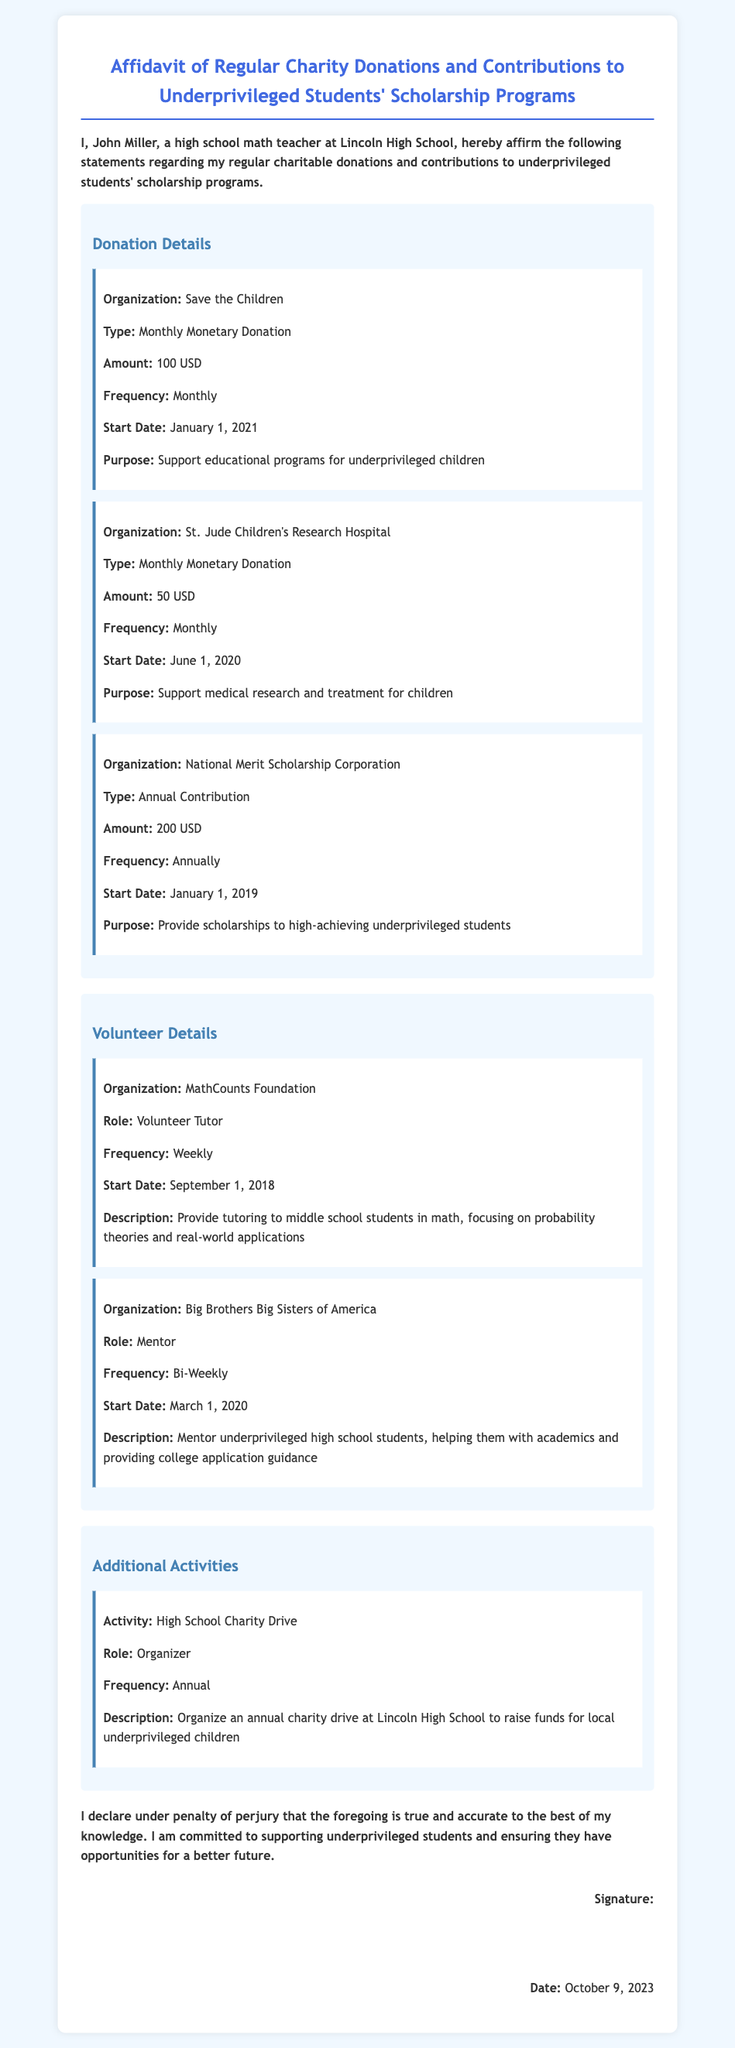What is the name of the person affirming the affidavit? The affidavit is affirmed by John Miller, as stated at the beginning of the document.
Answer: John Miller What organization receives a monthly donation of 100 USD? The donation item details specify that Save the Children receives a monthly donation of 100 USD.
Answer: Save the Children When did the donations to St. Jude Children's Research Hospital start? The start date for donations to St. Jude Children's Research Hospital is mentioned in the document as June 1, 2020.
Answer: June 1, 2020 What role does John Miller have at MathCounts Foundation? The document details that John Miller serves as a Volunteer Tutor at MathCounts Foundation.
Answer: Volunteer Tutor How frequently does John Miller volunteer with Big Brothers Big Sisters of America? The document states that John Miller volunteers bi-weekly with Big Brothers Big Sisters of America.
Answer: Bi-Weekly What is the total amount donated to the National Merit Scholarship Corporation annually? The affidavit indicates that the annual contribution to the National Merit Scholarship Corporation is 200 USD.
Answer: 200 USD What is the purpose of the donations to Save the Children? The document describes the purpose of the donations to Save the Children as supporting educational programs for underprivileged children.
Answer: Support educational programs for underprivileged children What activity does John Miller organize at Lincoln High School? The document mentions that John Miller organizes an annual charity drive at Lincoln High School.
Answer: Annual charity drive What declaration does John Miller make at the end of the affidavit? In the conclusion of the affidavit, John Miller declares that the statements are true and accurate to the best of his knowledge.
Answer: True and accurate to the best of my knowledge 